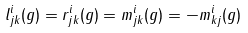<formula> <loc_0><loc_0><loc_500><loc_500>l ^ { i } _ { j k } ( g ) = r ^ { i } _ { j k } ( g ) = m ^ { i } _ { j k } ( g ) = - m ^ { i } _ { k j } ( g )</formula> 